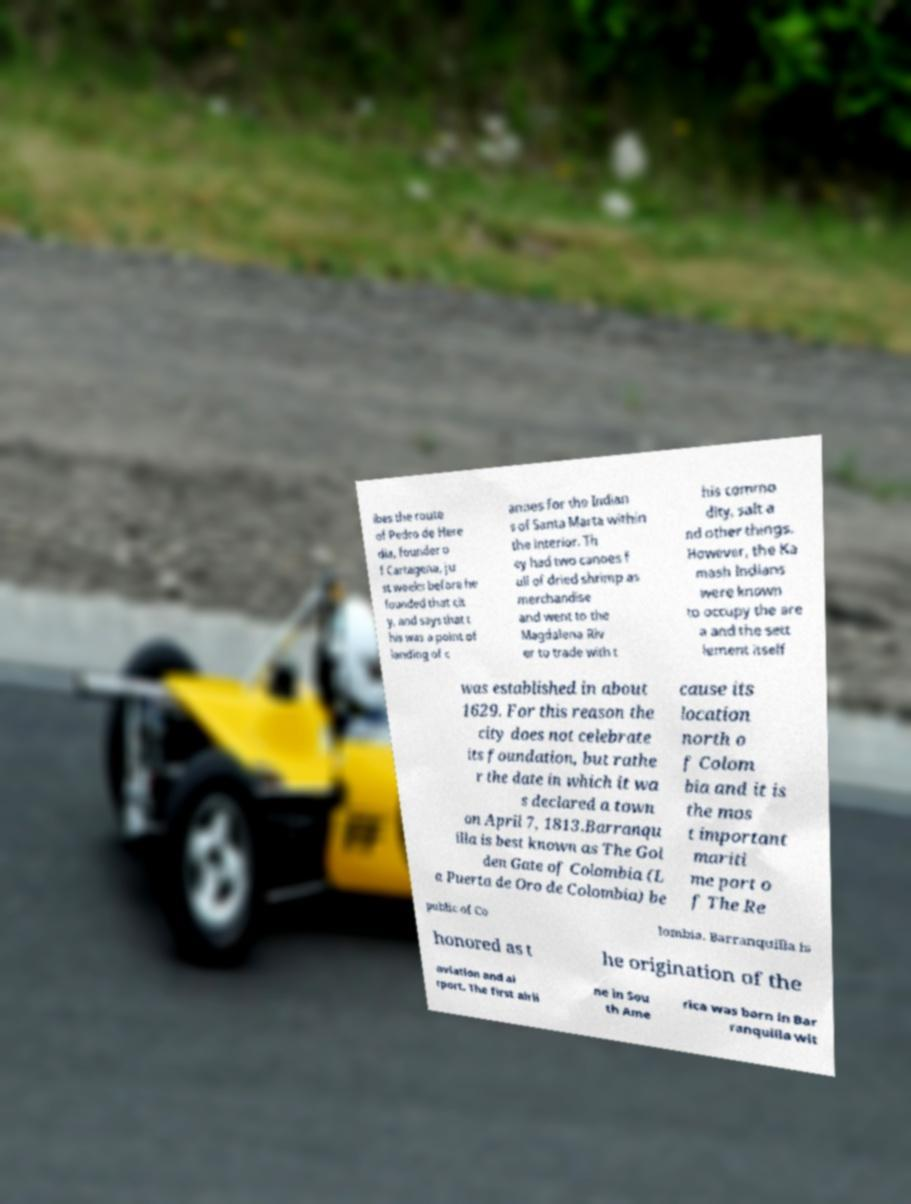Could you extract and type out the text from this image? ibes the route of Pedro de Here dia, founder o f Cartagena, ju st weeks before he founded that cit y, and says that t his was a point of landing of c anoes for the Indian s of Santa Marta within the interior. Th ey had two canoes f ull of dried shrimp as merchandise and went to the Magdalena Riv er to trade with t his commo dity, salt a nd other things. However, the Ka mash Indians were known to occupy the are a and the sett lement itself was established in about 1629. For this reason the city does not celebrate its foundation, but rathe r the date in which it wa s declared a town on April 7, 1813.Barranqu illa is best known as The Gol den Gate of Colombia (L a Puerta de Oro de Colombia) be cause its location north o f Colom bia and it is the mos t important mariti me port o f The Re public of Co lombia. Barranquilla is honored as t he origination of the aviation and ai rport. The first airli ne in Sou th Ame rica was born in Bar ranquilla wit 